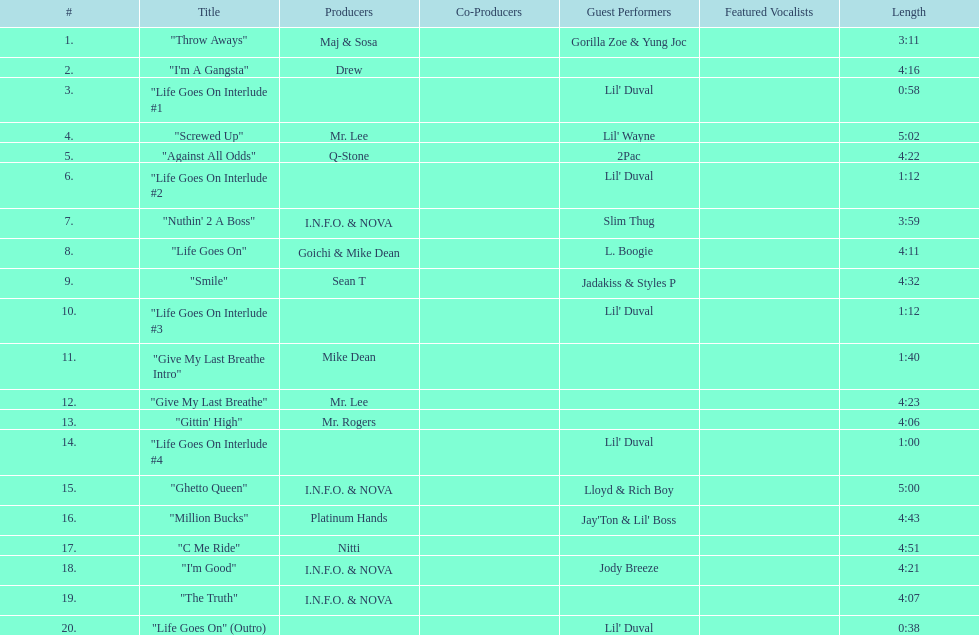What tracks appear on the album life goes on (trae album)? "Throw Aways", "I'm A Gangsta", "Life Goes On Interlude #1, "Screwed Up", "Against All Odds", "Life Goes On Interlude #2, "Nuthin' 2 A Boss", "Life Goes On", "Smile", "Life Goes On Interlude #3, "Give My Last Breathe Intro", "Give My Last Breathe", "Gittin' High", "Life Goes On Interlude #4, "Ghetto Queen", "Million Bucks", "C Me Ride", "I'm Good", "The Truth", "Life Goes On" (Outro). Which of these songs are at least 5 minutes long? "Screwed Up", "Ghetto Queen". Of these two songs over 5 minutes long, which is longer? "Screwed Up". How long is this track? 5:02. 